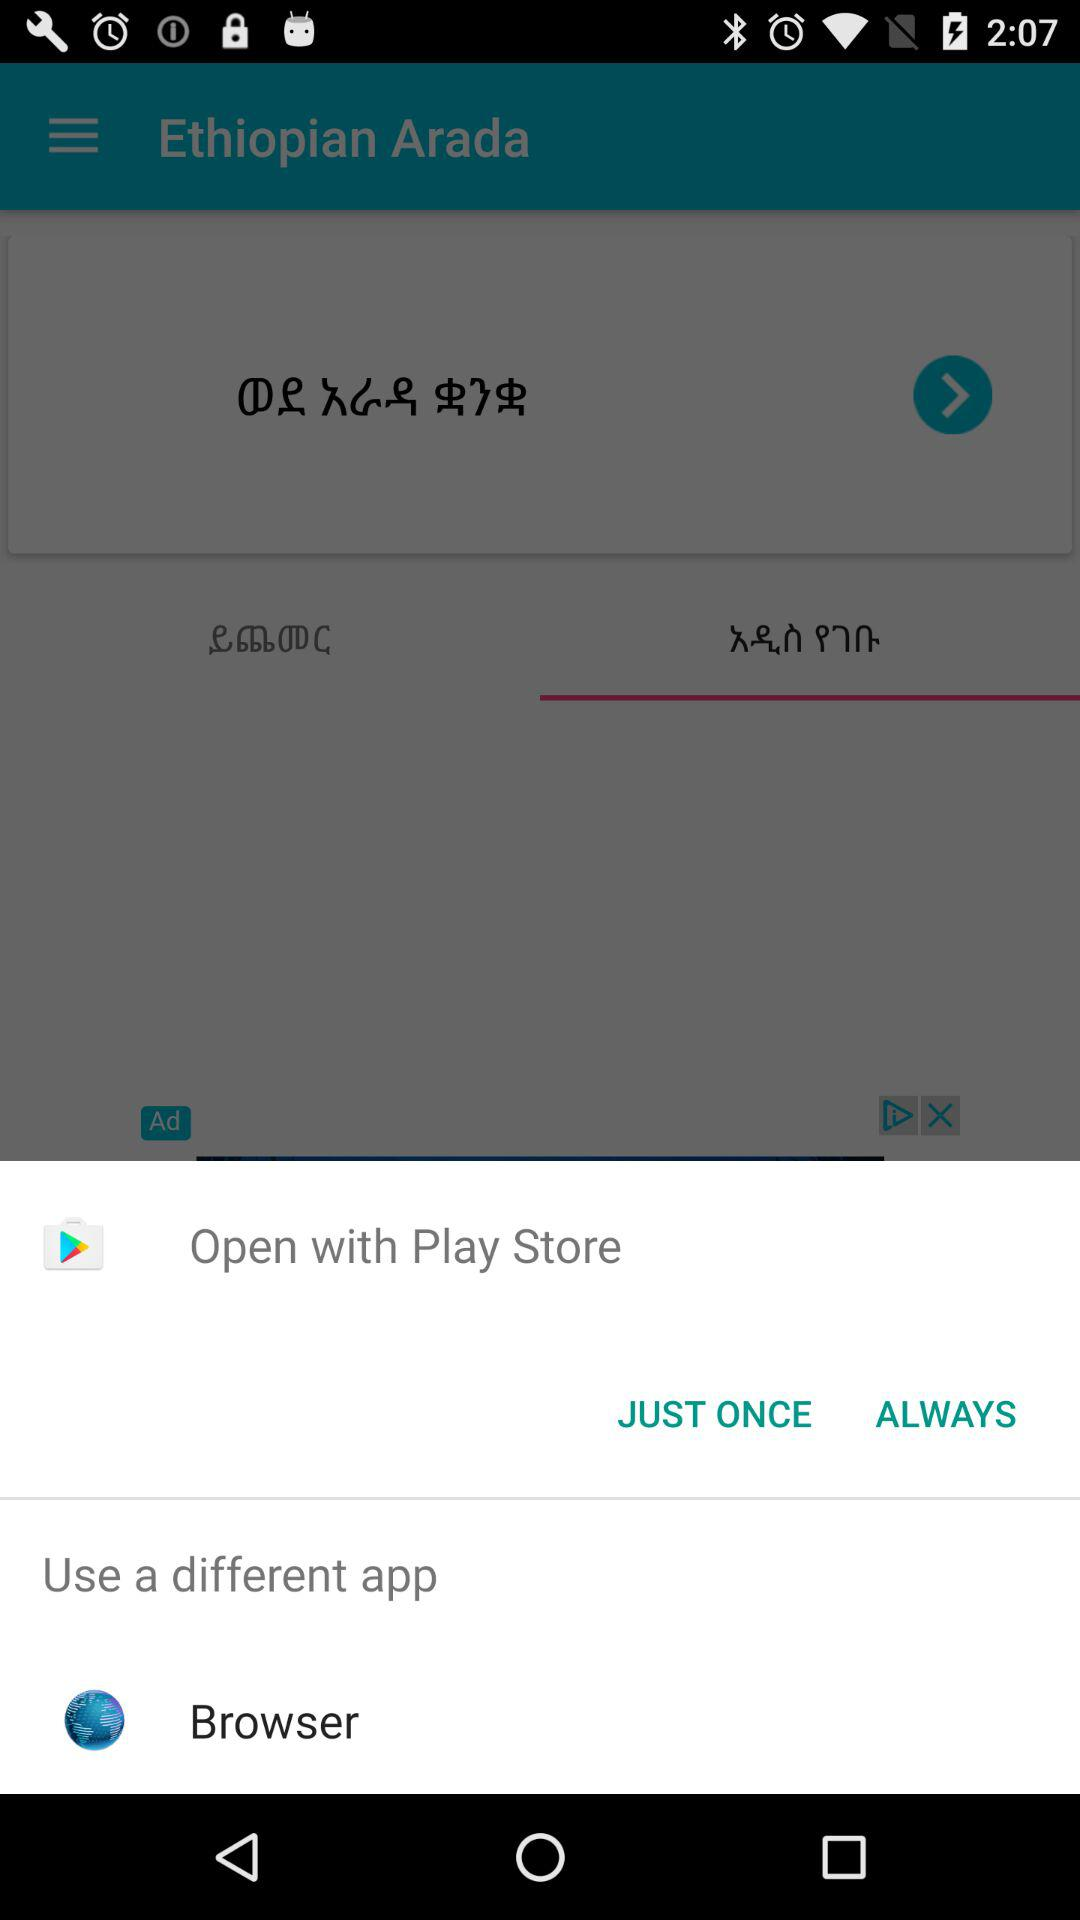Which is a different app to use? The different app to use is "Browser". 